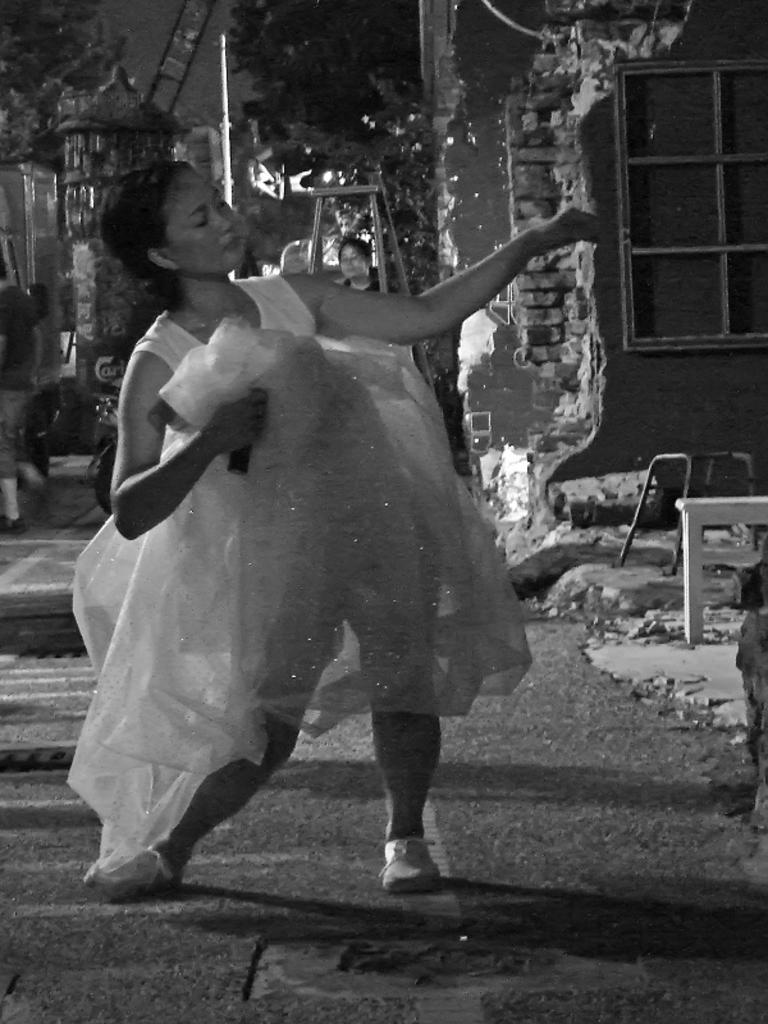Please provide a concise description of this image. This is a black and white picture. I can see a woman standing, there are stools, this is looking like a house, this is looking like a ladder, there is another person, there are trees and some other objects. 